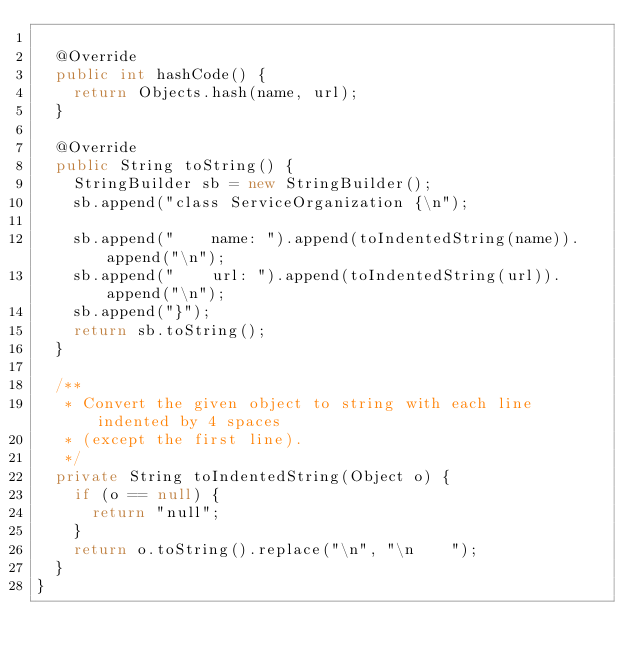Convert code to text. <code><loc_0><loc_0><loc_500><loc_500><_Java_>
  @Override
  public int hashCode() {
    return Objects.hash(name, url);
  }

  @Override
  public String toString() {
    StringBuilder sb = new StringBuilder();
    sb.append("class ServiceOrganization {\n");
    
    sb.append("    name: ").append(toIndentedString(name)).append("\n");
    sb.append("    url: ").append(toIndentedString(url)).append("\n");
    sb.append("}");
    return sb.toString();
  }

  /**
   * Convert the given object to string with each line indented by 4 spaces
   * (except the first line).
   */
  private String toIndentedString(Object o) {
    if (o == null) {
      return "null";
    }
    return o.toString().replace("\n", "\n    ");
  }
}

</code> 